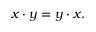Convert formula to latex. <formula><loc_0><loc_0><loc_500><loc_500>x \cdot y = y \cdot x .</formula> 